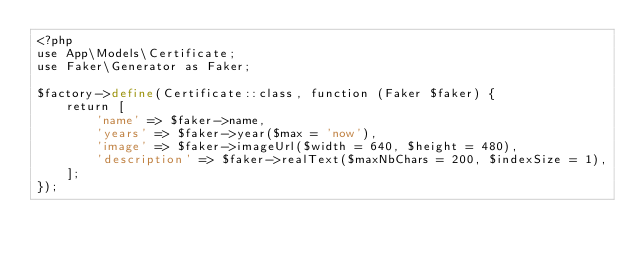<code> <loc_0><loc_0><loc_500><loc_500><_PHP_><?php
use App\Models\Certificate;
use Faker\Generator as Faker;

$factory->define(Certificate::class, function (Faker $faker) {
    return [
		'name' => $faker->name,
        'years' => $faker->year($max = 'now'),
        'image' => $faker->imageUrl($width = 640, $height = 480),
        'description' => $faker->realText($maxNbChars = 200, $indexSize = 1),
    ];
});
</code> 